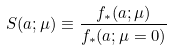Convert formula to latex. <formula><loc_0><loc_0><loc_500><loc_500>S ( a ; \mu ) \equiv \frac { f _ { \ast } ( a ; \mu ) } { f _ { \ast } ( a ; \mu = 0 ) }</formula> 